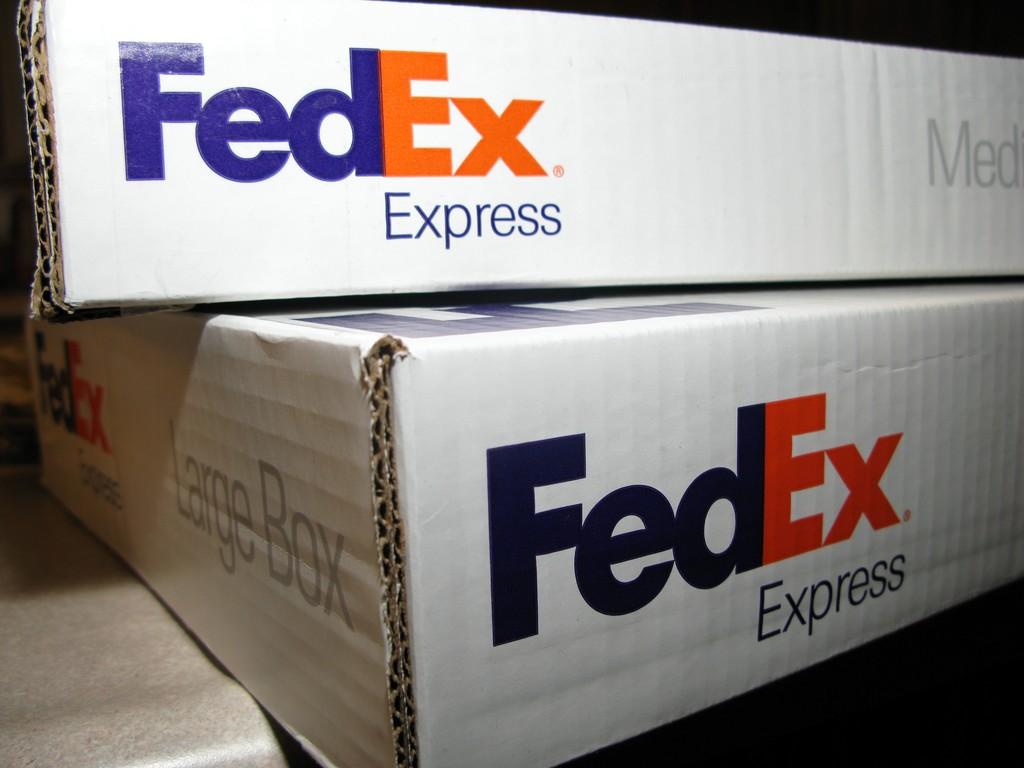Which carrier are these boxes from?
Keep it short and to the point. Fedex. 